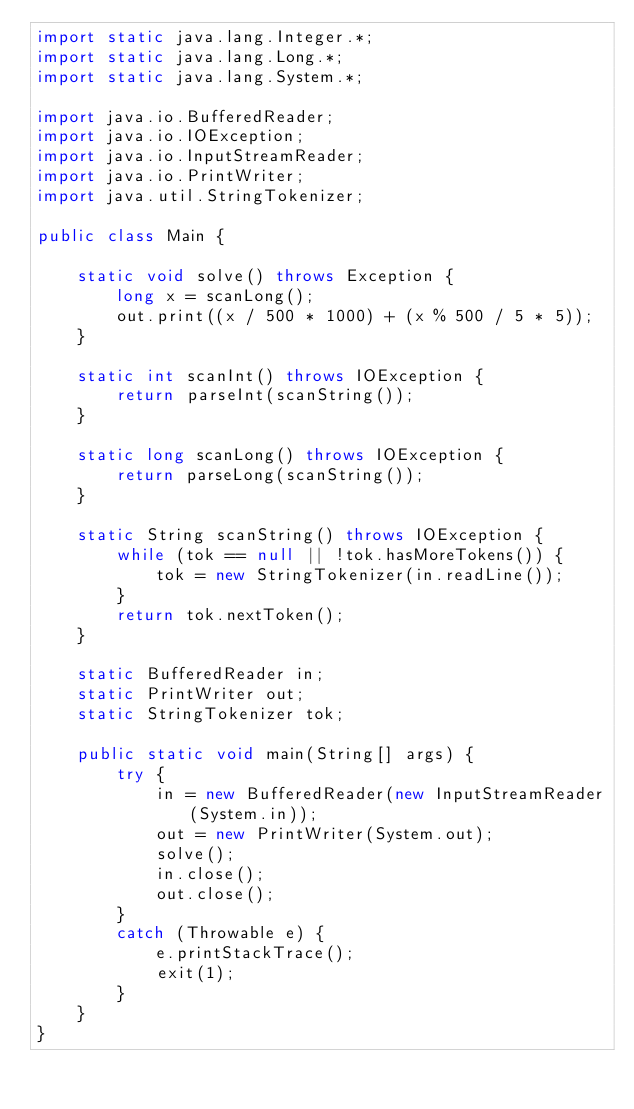Convert code to text. <code><loc_0><loc_0><loc_500><loc_500><_Java_>import static java.lang.Integer.*;
import static java.lang.Long.*;
import static java.lang.System.*;

import java.io.BufferedReader;
import java.io.IOException;
import java.io.InputStreamReader;
import java.io.PrintWriter;
import java.util.StringTokenizer;

public class Main {

    static void solve() throws Exception {
        long x = scanLong();
        out.print((x / 500 * 1000) + (x % 500 / 5 * 5));
    }

    static int scanInt() throws IOException {
        return parseInt(scanString());
    }

    static long scanLong() throws IOException {
        return parseLong(scanString());
    }

    static String scanString() throws IOException {
        while (tok == null || !tok.hasMoreTokens()) {
            tok = new StringTokenizer(in.readLine());
        }
        return tok.nextToken();
    }

    static BufferedReader in;
    static PrintWriter out;
    static StringTokenizer tok;

    public static void main(String[] args) {
        try {
            in = new BufferedReader(new InputStreamReader(System.in));
            out = new PrintWriter(System.out);
            solve();
            in.close();
            out.close();
        }
        catch (Throwable e) {
            e.printStackTrace();
            exit(1);
        }
    }
}</code> 